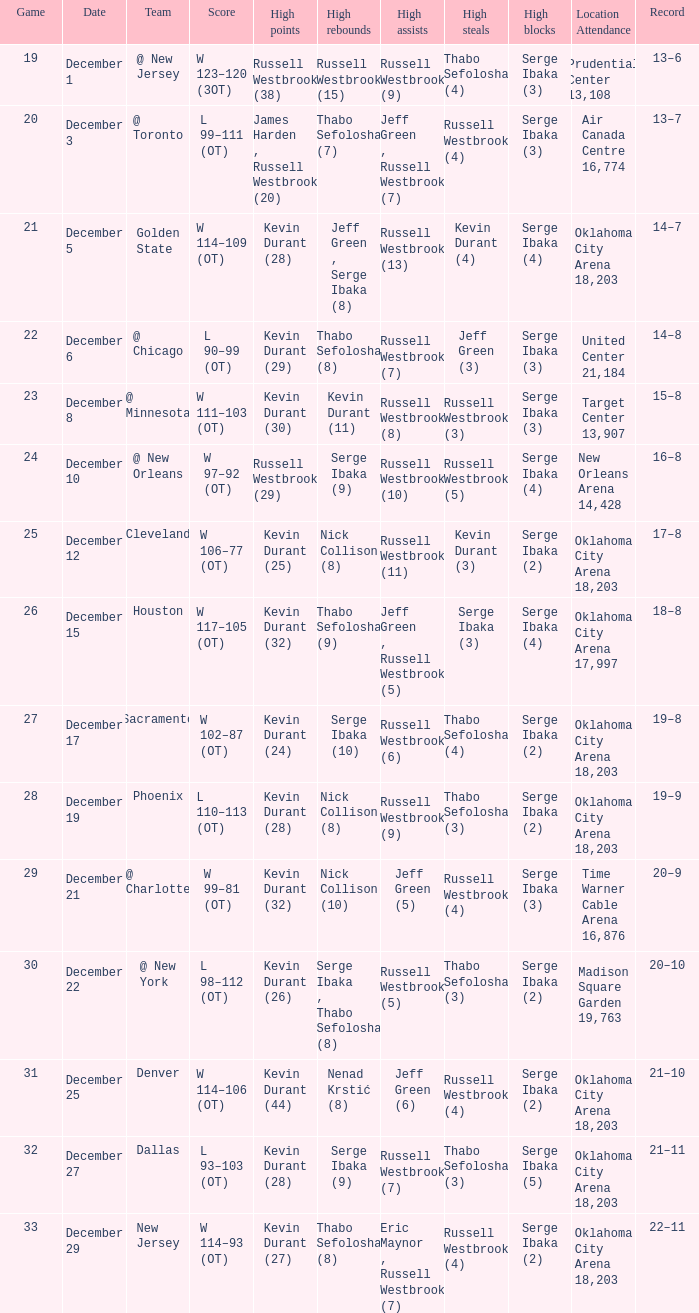On december 12, who held the record for the most rebounds? Nick Collison (8). 